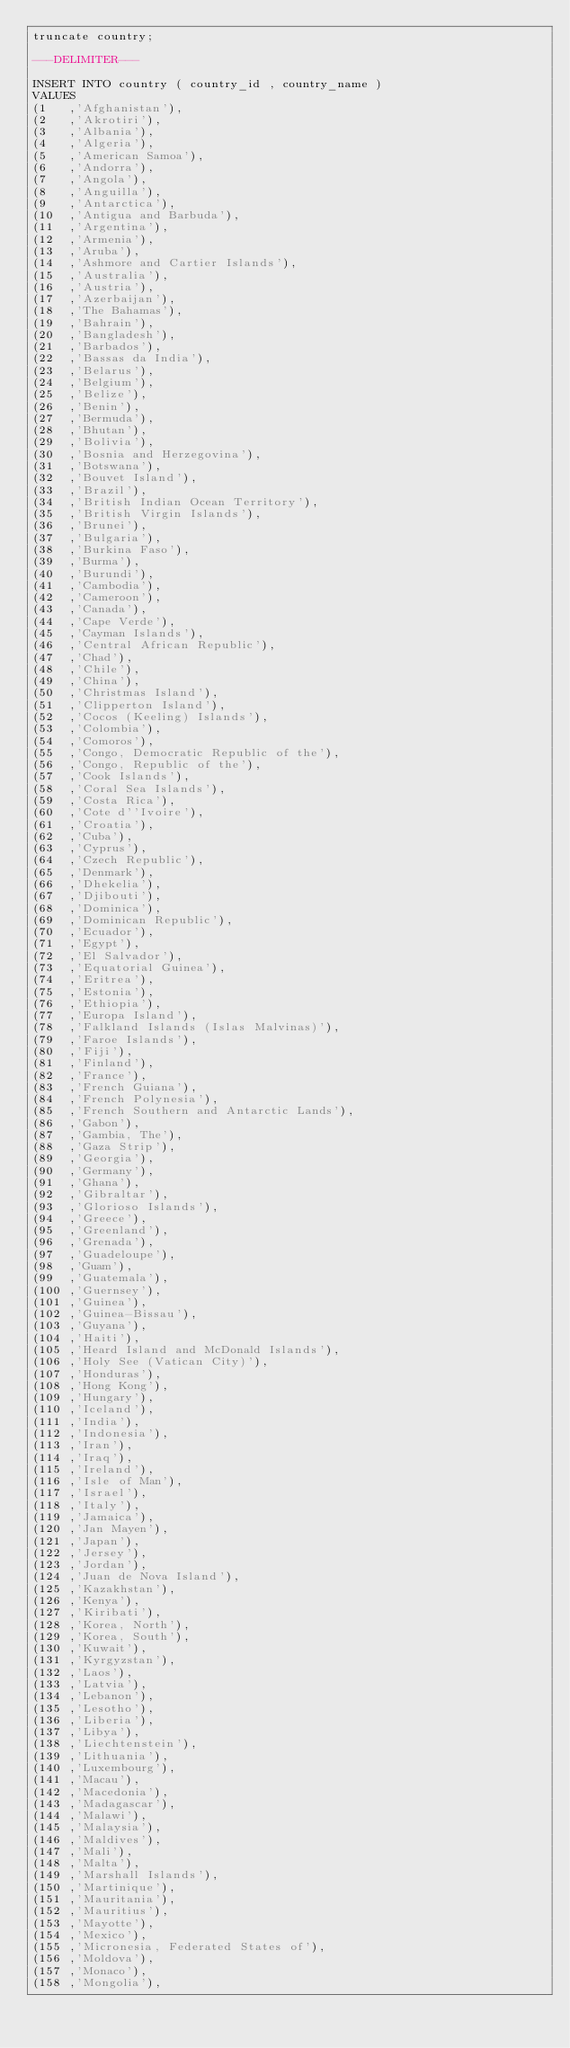<code> <loc_0><loc_0><loc_500><loc_500><_SQL_>truncate country;

---DELIMITER---

INSERT INTO country ( country_id , country_name )
VALUES
(1   ,'Afghanistan'),
(2   ,'Akrotiri'),
(3   ,'Albania'),
(4   ,'Algeria'),
(5   ,'American Samoa'),
(6   ,'Andorra'),
(7   ,'Angola'),
(8   ,'Anguilla'),
(9   ,'Antarctica'),
(10  ,'Antigua and Barbuda'),
(11  ,'Argentina'),
(12  ,'Armenia'),
(13  ,'Aruba'),
(14  ,'Ashmore and Cartier Islands'),
(15  ,'Australia'),
(16  ,'Austria'),
(17  ,'Azerbaijan'),
(18  ,'The Bahamas'),
(19  ,'Bahrain'),
(20  ,'Bangladesh'),
(21  ,'Barbados'),
(22  ,'Bassas da India'),
(23  ,'Belarus'),
(24  ,'Belgium'),
(25  ,'Belize'),
(26  ,'Benin'),
(27  ,'Bermuda'),
(28  ,'Bhutan'),
(29  ,'Bolivia'),
(30  ,'Bosnia and Herzegovina'),
(31  ,'Botswana'),
(32  ,'Bouvet Island'),
(33  ,'Brazil'),
(34  ,'British Indian Ocean Territory'),
(35  ,'British Virgin Islands'),
(36  ,'Brunei'),
(37  ,'Bulgaria'),
(38  ,'Burkina Faso'),
(39  ,'Burma'),
(40  ,'Burundi'),
(41  ,'Cambodia'),
(42  ,'Cameroon'),
(43  ,'Canada'),
(44  ,'Cape Verde'),
(45  ,'Cayman Islands'),
(46  ,'Central African Republic'),
(47  ,'Chad'),
(48  ,'Chile'),
(49  ,'China'),
(50  ,'Christmas Island'),
(51  ,'Clipperton Island'),
(52  ,'Cocos (Keeling) Islands'),
(53  ,'Colombia'),
(54  ,'Comoros'),
(55  ,'Congo, Democratic Republic of the'),
(56  ,'Congo, Republic of the'),
(57  ,'Cook Islands'),
(58  ,'Coral Sea Islands'),
(59  ,'Costa Rica'),
(60  ,'Cote d''Ivoire'),
(61  ,'Croatia'),
(62  ,'Cuba'),
(63  ,'Cyprus'),
(64  ,'Czech Republic'),
(65  ,'Denmark'),
(66  ,'Dhekelia'),
(67  ,'Djibouti'),
(68  ,'Dominica'),
(69  ,'Dominican Republic'),
(70  ,'Ecuador'),
(71  ,'Egypt'),
(72  ,'El Salvador'),
(73  ,'Equatorial Guinea'),
(74  ,'Eritrea'),
(75  ,'Estonia'),
(76  ,'Ethiopia'),
(77  ,'Europa Island'),
(78  ,'Falkland Islands (Islas Malvinas)'),
(79  ,'Faroe Islands'),
(80  ,'Fiji'),
(81  ,'Finland'),
(82  ,'France'),
(83  ,'French Guiana'),
(84  ,'French Polynesia'),
(85  ,'French Southern and Antarctic Lands'),
(86  ,'Gabon'),
(87  ,'Gambia, The'),
(88  ,'Gaza Strip'),
(89  ,'Georgia'),
(90  ,'Germany'),
(91  ,'Ghana'),
(92  ,'Gibraltar'),
(93  ,'Glorioso Islands'),
(94  ,'Greece'),
(95  ,'Greenland'),
(96  ,'Grenada'),
(97  ,'Guadeloupe'),
(98  ,'Guam'),
(99  ,'Guatemala'),
(100 ,'Guernsey'),
(101 ,'Guinea'),
(102 ,'Guinea-Bissau'),
(103 ,'Guyana'),
(104 ,'Haiti'),
(105 ,'Heard Island and McDonald Islands'),
(106 ,'Holy See (Vatican City)'),
(107 ,'Honduras'),
(108 ,'Hong Kong'),
(109 ,'Hungary'),
(110 ,'Iceland'),
(111 ,'India'),
(112 ,'Indonesia'),
(113 ,'Iran'),
(114 ,'Iraq'),
(115 ,'Ireland'),
(116 ,'Isle of Man'),
(117 ,'Israel'),
(118 ,'Italy'),
(119 ,'Jamaica'),
(120 ,'Jan Mayen'),
(121 ,'Japan'),
(122 ,'Jersey'),
(123 ,'Jordan'),
(124 ,'Juan de Nova Island'),
(125 ,'Kazakhstan'),
(126 ,'Kenya'),
(127 ,'Kiribati'),
(128 ,'Korea, North'),
(129 ,'Korea, South'),
(130 ,'Kuwait'),
(131 ,'Kyrgyzstan'),
(132 ,'Laos'),
(133 ,'Latvia'),
(134 ,'Lebanon'),
(135 ,'Lesotho'),
(136 ,'Liberia'),
(137 ,'Libya'),
(138 ,'Liechtenstein'),
(139 ,'Lithuania'),
(140 ,'Luxembourg'),
(141 ,'Macau'),
(142 ,'Macedonia'),
(143 ,'Madagascar'),
(144 ,'Malawi'),
(145 ,'Malaysia'),
(146 ,'Maldives'),
(147 ,'Mali'),
(148 ,'Malta'),
(149 ,'Marshall Islands'),
(150 ,'Martinique'),
(151 ,'Mauritania'),
(152 ,'Mauritius'),
(153 ,'Mayotte'),
(154 ,'Mexico'),
(155 ,'Micronesia, Federated States of'),
(156 ,'Moldova'),
(157 ,'Monaco'),
(158 ,'Mongolia'),</code> 